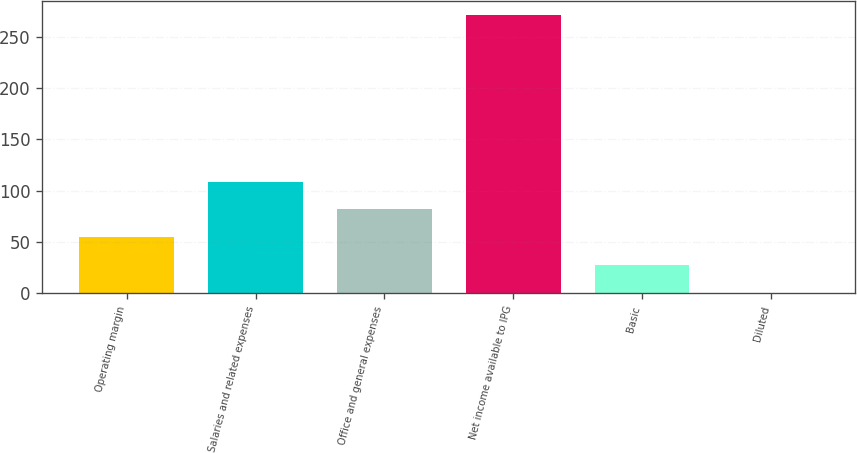Convert chart to OTSL. <chart><loc_0><loc_0><loc_500><loc_500><bar_chart><fcel>Operating margin<fcel>Salaries and related expenses<fcel>Office and general expenses<fcel>Net income available to IPG<fcel>Basic<fcel>Diluted<nl><fcel>54.61<fcel>108.75<fcel>81.68<fcel>271.2<fcel>27.54<fcel>0.47<nl></chart> 